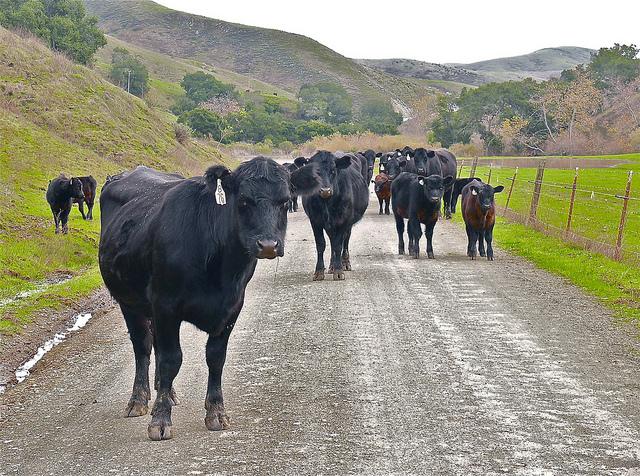What would these animals eat?
Keep it brief. Grass. Which animals are these?
Write a very short answer. Cows. What sound would these animals make?
Be succinct. Moo. 